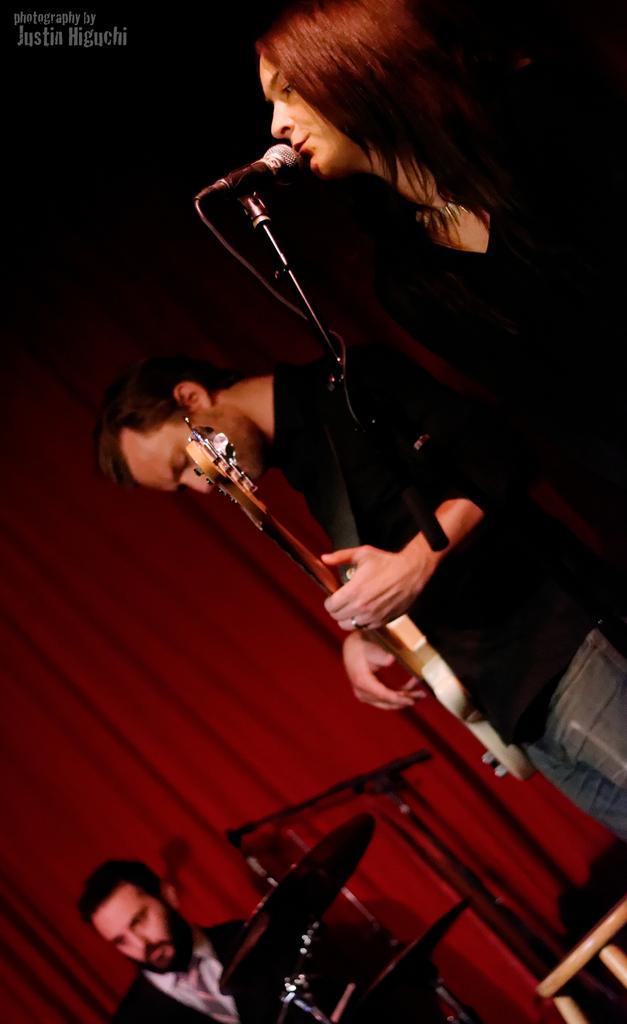Describe this image in one or two sentences. In this image can see a woman is singing the song. In front of her there is a mike. Just beside their or there is a man standing and playing the guitar. On the bottom of the image I can see another person who is playing the drums. In the background there is a red color curtain. 